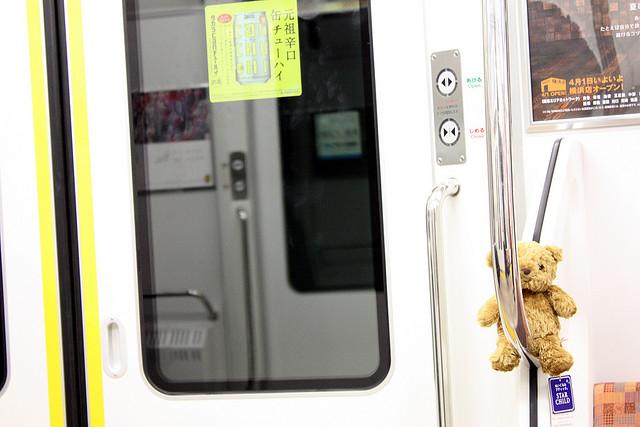What color are the stripes to the left of the door?
Answer briefly. Yellow. Is there a stuffed animal?
Short answer required. Yes. Was this picture taken inside the train?
Keep it brief. Yes. 